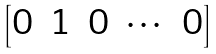<formula> <loc_0><loc_0><loc_500><loc_500>\begin{bmatrix} 0 & 1 & 0 & \cdots & 0 \end{bmatrix}</formula> 